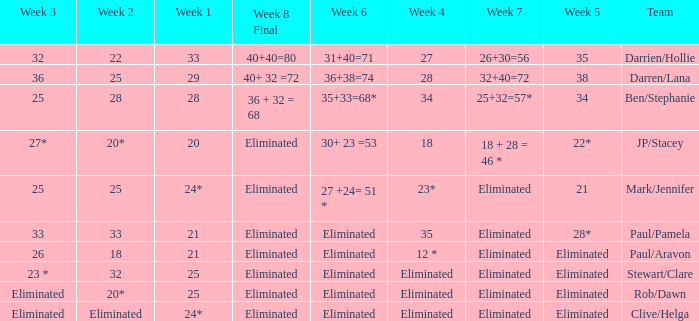Name the week 6 when week 3 is 25 and week 7 is eliminated 27 +24= 51 *. 